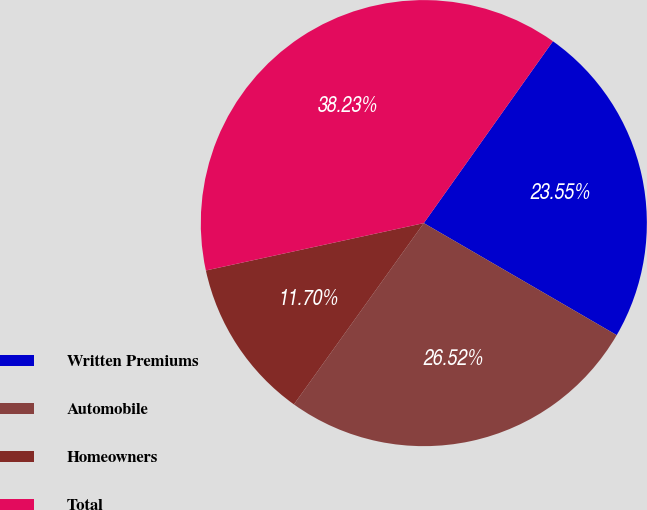Convert chart to OTSL. <chart><loc_0><loc_0><loc_500><loc_500><pie_chart><fcel>Written Premiums<fcel>Automobile<fcel>Homeowners<fcel>Total<nl><fcel>23.55%<fcel>26.52%<fcel>11.7%<fcel>38.23%<nl></chart> 